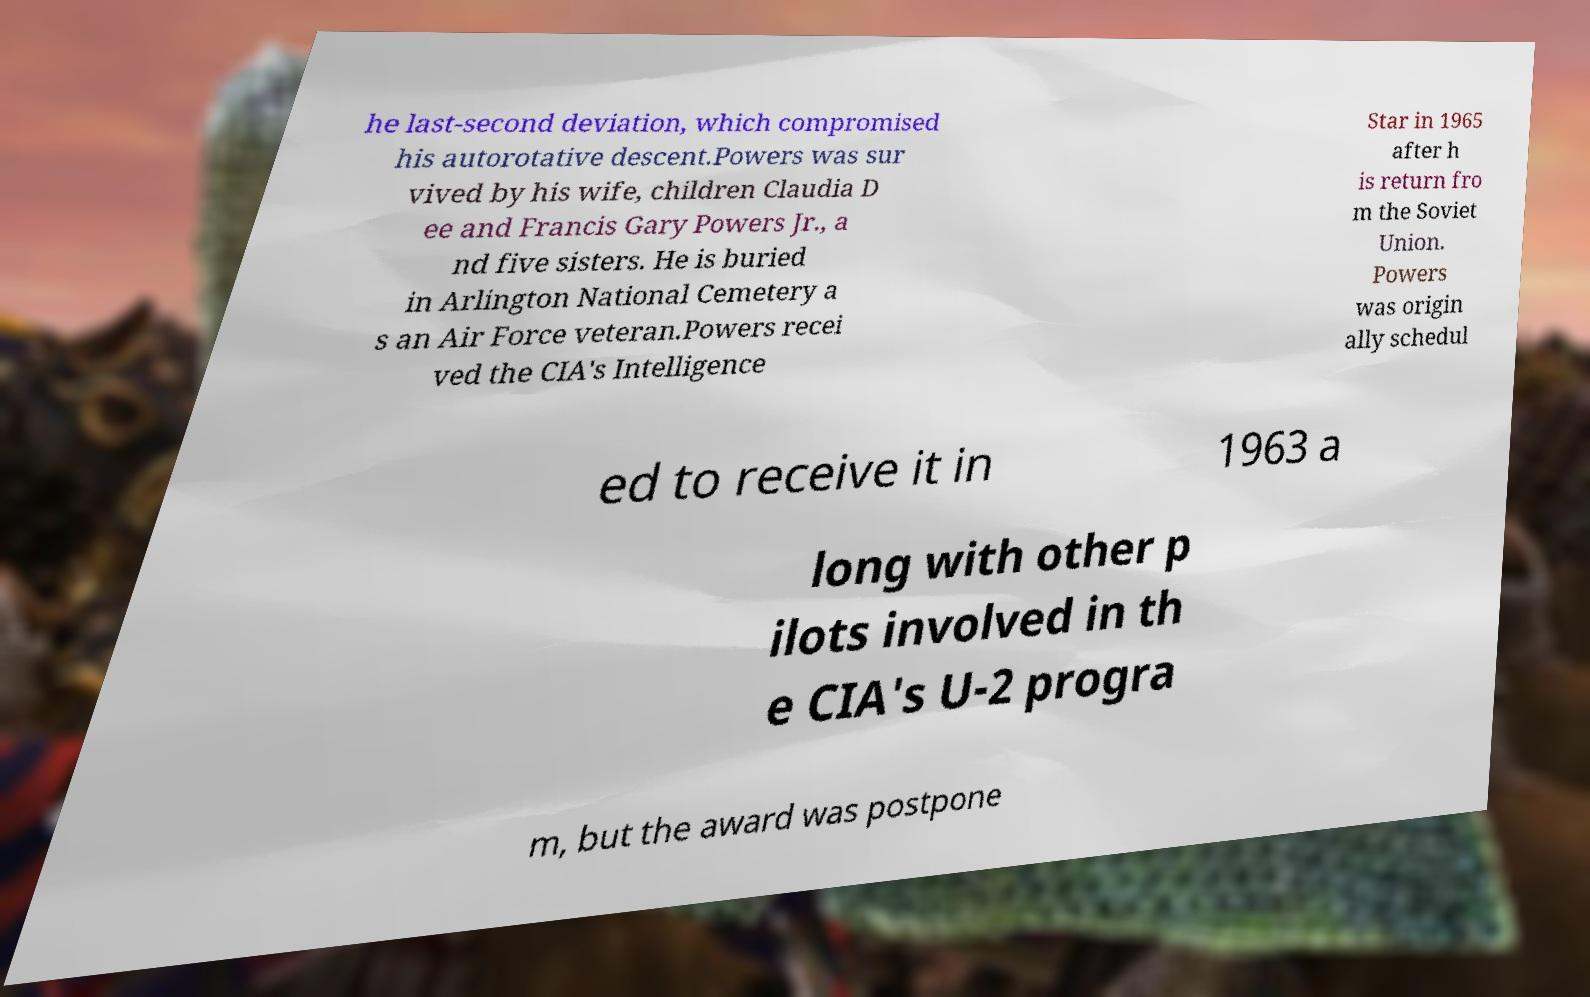What messages or text are displayed in this image? I need them in a readable, typed format. he last-second deviation, which compromised his autorotative descent.Powers was sur vived by his wife, children Claudia D ee and Francis Gary Powers Jr., a nd five sisters. He is buried in Arlington National Cemetery a s an Air Force veteran.Powers recei ved the CIA's Intelligence Star in 1965 after h is return fro m the Soviet Union. Powers was origin ally schedul ed to receive it in 1963 a long with other p ilots involved in th e CIA's U-2 progra m, but the award was postpone 